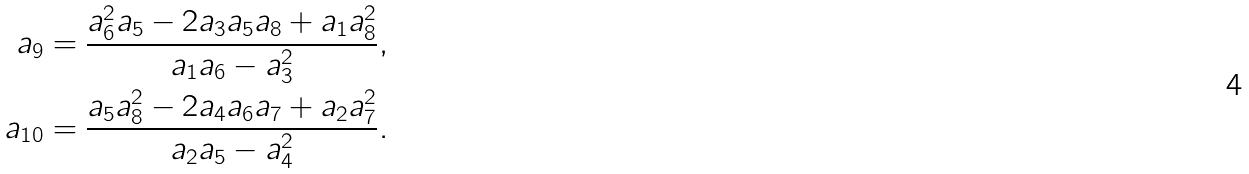<formula> <loc_0><loc_0><loc_500><loc_500>a _ { 9 } = \frac { a _ { 6 } ^ { 2 } a _ { 5 } - 2 a _ { 3 } a _ { 5 } a _ { 8 } + a _ { 1 } a _ { 8 } ^ { 2 } } { a _ { 1 } a _ { 6 } - a _ { 3 } ^ { 2 } } , \\ a _ { 1 0 } = \frac { a _ { 5 } a _ { 8 } ^ { 2 } - 2 a _ { 4 } a _ { 6 } a _ { 7 } + a _ { 2 } a _ { 7 } ^ { 2 } } { a _ { 2 } a _ { 5 } - a _ { 4 } ^ { 2 } } .</formula> 